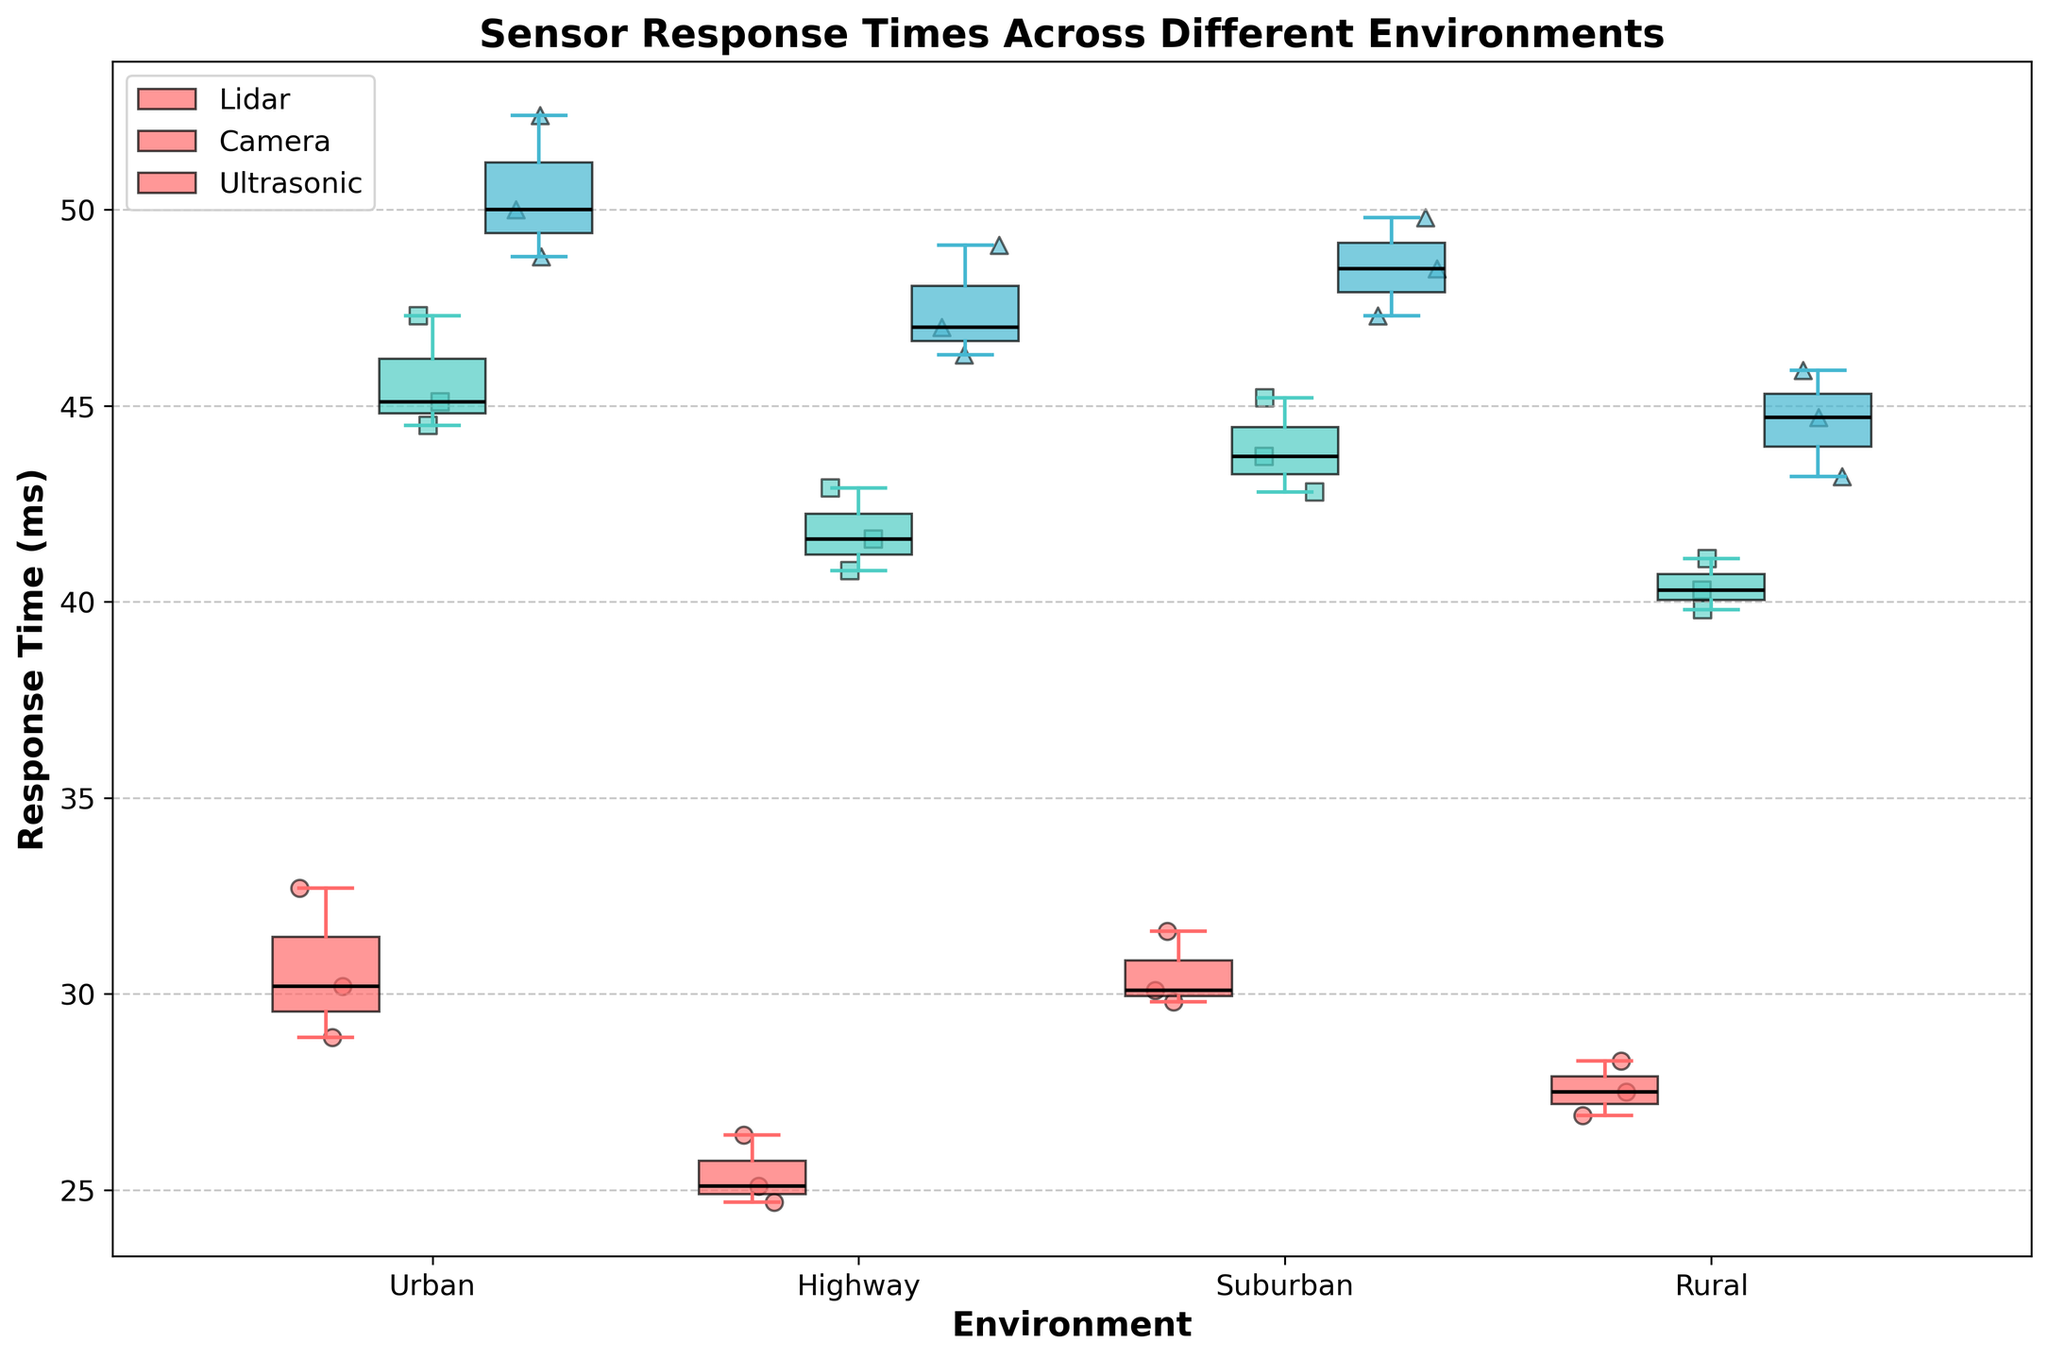What is the title of the plot? The title is usually displayed at the top of the figure. In this case, it reads "Sensor Response Times Across Different Environments".
Answer: Sensor Response Times Across Different Environments How many environments are represented in the plot? The plot's x-axis lists the different environments. The figure shows four distinct categories: Urban, Highway, Suburban, and Rural.
Answer: 4 Which sensor has the highest median response time in an Urban environment? The median is represented by the black line inside the box of each box plot. The median response time for Camera is the highest among Lidar, Camera, and Ultrasonic in an Urban environment.
Answer: Camera What is the average response time of the Lidar sensor in a Rural environment? There are three data points for Lidar in Rural: 27.5, 28.3, and 26.9. Sum them (27.5 + 28.3 + 26.9 = 82.7) and then divide by the number of points (82.7 / 3).
Answer: 27.57 ms Which environment has the most consistent Lidar sensor response times? Consistency can be measured by the interquartile range (IQR), which is the box length. The Rural environment has the shortest IQR for Lidar, indicating the most consistent response times.
Answer: Rural How does the spread of Camera sensor response times in a Highway environment compare to an Urban environment? The spread can be gauged by the length of the whiskers. The whiskers in the Urban environment are longer than those in the Highway environment, indicating a larger spread in response times for the Camera sensor.
Answer: Larger spread in Urban Which sensor shows the greatest variability in the Suburban environment? Variability is indicated by the length of the whiskers and IQR. The Ultrasonic sensor has the widest whiskers and box in Suburban, suggesting the greatest variability.
Answer: Ultrasonic What pattern do you observe for the median response times of Ultrasonic sensors across different environments? Observing the black lines inside the Ultrasonic sensor boxes across environments, the median response times increase from Highway, Rural, Suburban, to Urban.
Answer: Increases from Highway to Urban Are there any outliers displayed in the plot? Outliers are typically represented by individual points outside the whiskers. The plot does not show any points outside the whiskers, indicating no outliers for any sensor in any environment.
Answer: No Which sensor has the smallest interquartile range (IQR) in the Highway environment? The IQR is the length of the box in the box plot. The Lidar sensor has the smallest IQR in the Highway environment compared to Camera and Ultrasonic.
Answer: Lidar 